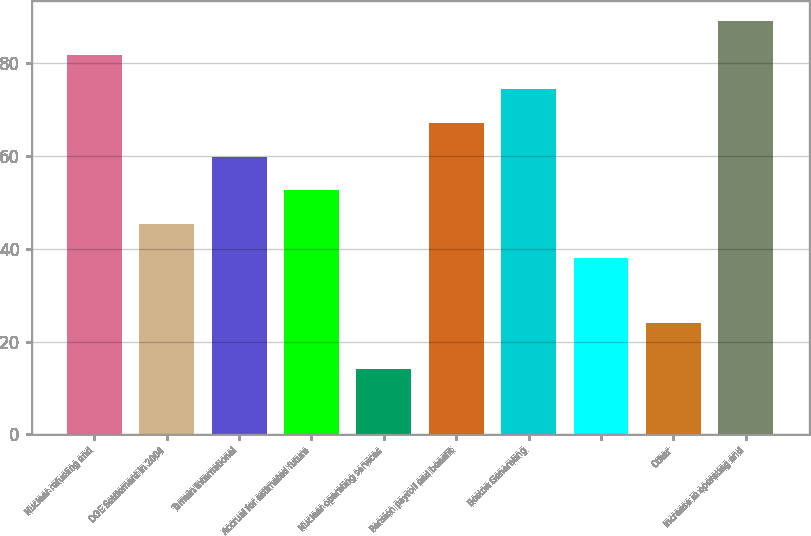Convert chart to OTSL. <chart><loc_0><loc_0><loc_500><loc_500><bar_chart><fcel>Nuclear refueling and<fcel>DOE Settlement in 2004<fcel>Tamuin International<fcel>Accrual for estimated future<fcel>Nuclear operating services<fcel>Pension payroll and benefit<fcel>Boston Generating<fcel>Unnamed: 7<fcel>Other<fcel>Increase in operating and<nl><fcel>81.8<fcel>45.3<fcel>59.9<fcel>52.6<fcel>14<fcel>67.2<fcel>74.5<fcel>38<fcel>24<fcel>89.1<nl></chart> 